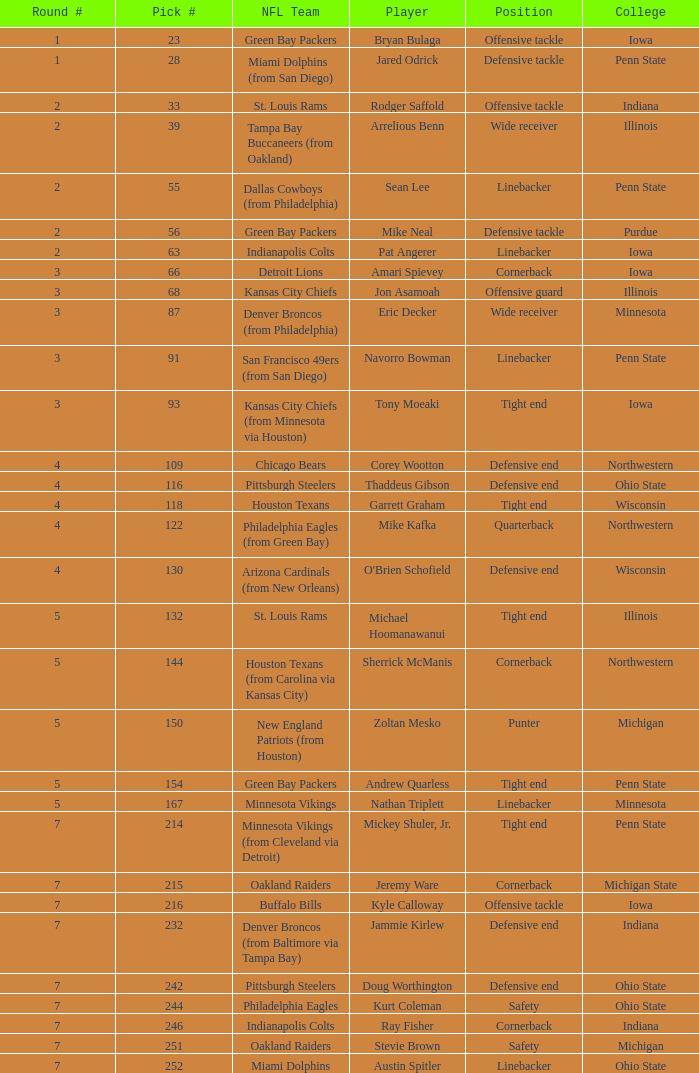To which nfl team was the athlete with the 28th pick drafted? Miami Dolphins (from San Diego). 